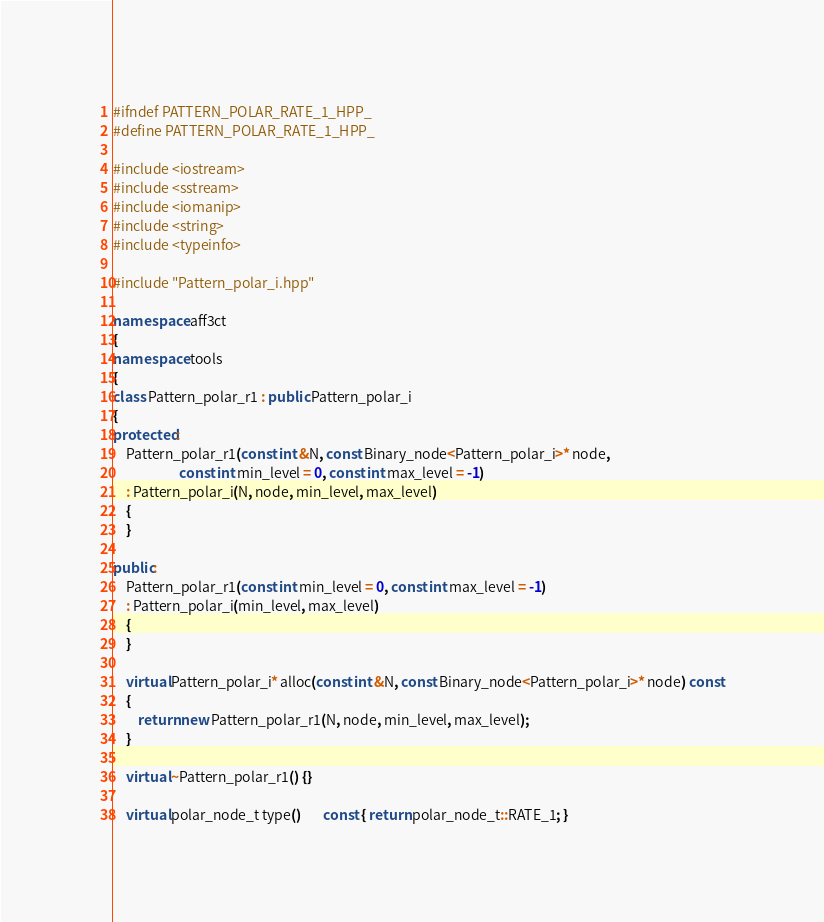<code> <loc_0><loc_0><loc_500><loc_500><_C++_>#ifndef PATTERN_POLAR_RATE_1_HPP_
#define PATTERN_POLAR_RATE_1_HPP_

#include <iostream>
#include <sstream>
#include <iomanip>
#include <string>
#include <typeinfo>

#include "Pattern_polar_i.hpp"

namespace aff3ct
{
namespace tools
{
class Pattern_polar_r1 : public Pattern_polar_i
{
protected:
	Pattern_polar_r1(const int &N, const Binary_node<Pattern_polar_i>* node,
	                 const int min_level = 0, const int max_level = -1)
	: Pattern_polar_i(N, node, min_level, max_level)
	{
	}

public:
	Pattern_polar_r1(const int min_level = 0, const int max_level = -1)
	: Pattern_polar_i(min_level, max_level)
	{
	}

	virtual Pattern_polar_i* alloc(const int &N, const Binary_node<Pattern_polar_i>* node) const
	{
		return new Pattern_polar_r1(N, node, min_level, max_level);
	}

	virtual ~Pattern_polar_r1() {}

	virtual polar_node_t type()       const { return polar_node_t::RATE_1; }</code> 